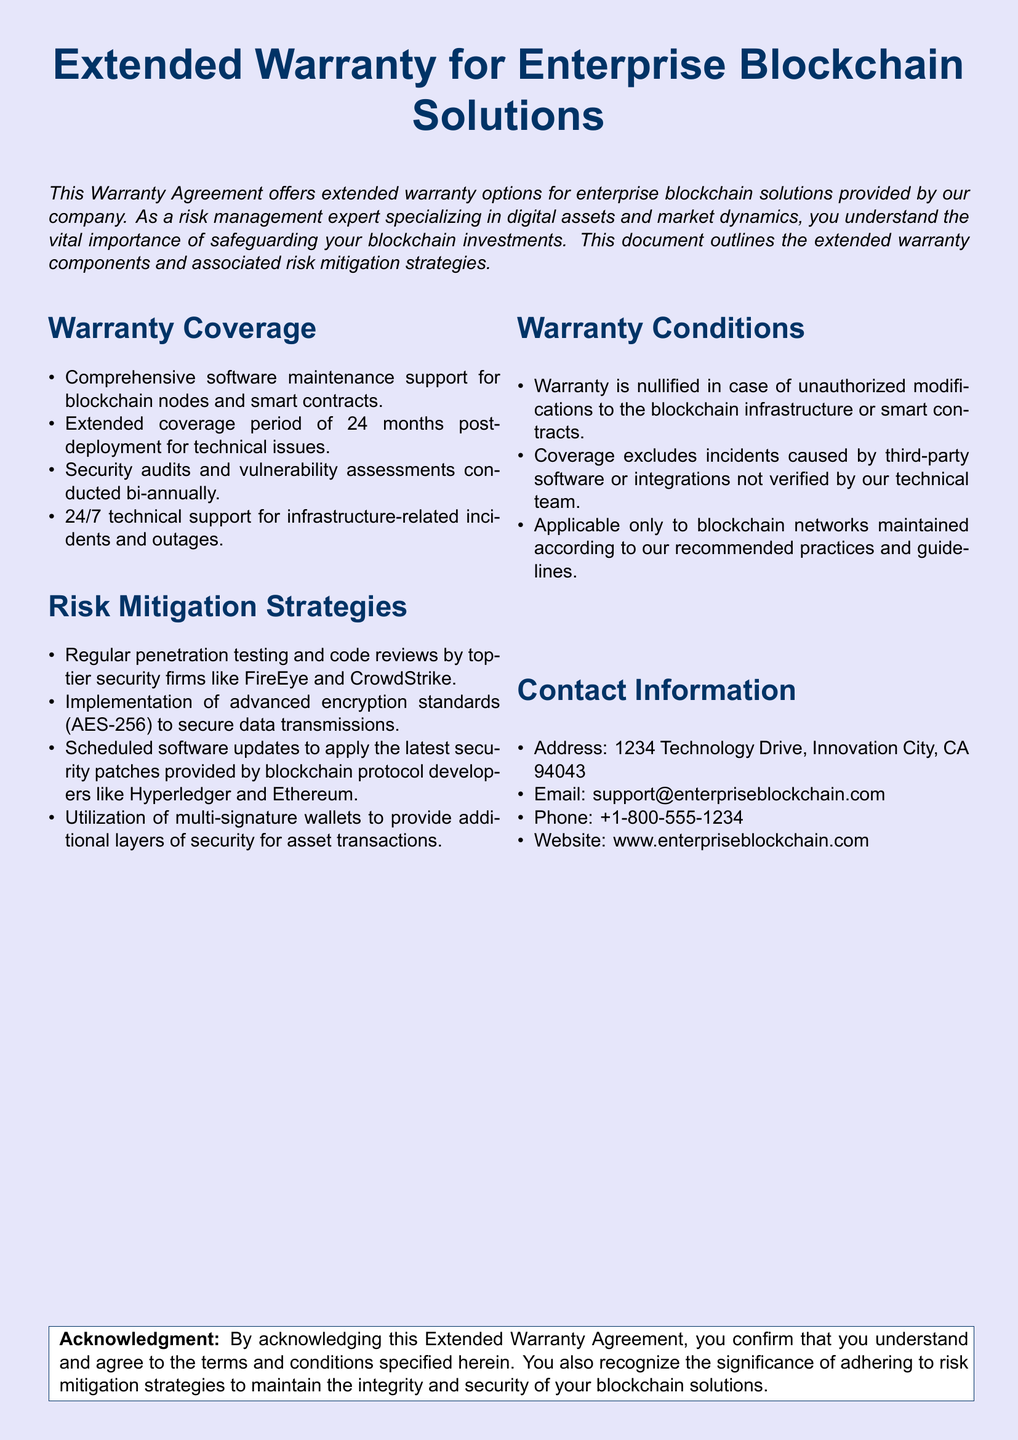What is the extended coverage period for technical issues? The extended coverage period for technical issues is clearly stated in the document.
Answer: 24 months What type of technical support is provided? The document specifies the kind of technical support included in the warranty agreement.
Answer: 24/7 technical support Which companies conduct the penetration testing? The document names the security firms responsible for conducting penetration testing and code reviews.
Answer: FireEye and CrowdStrike What encryption standard is implemented for data transmissions? The document mentions the encryption standard used to secure data transfers.
Answer: AES-256 What happens if there are unauthorized modifications made? The document outlines a specific condition under which the warranty becomes nullified.
Answer: Warranty is nullified What type of infrastructure incidents does the warranty cover? The document details the kinds of incidents related to infrastructure that are covered by the warranty.
Answer: Infrastructure-related incidents What is the contact email provided in the document? The document includes contact information including email for support queries.
Answer: support@enterpriseblockchain.com How often are security audits conducted? The document specifies the frequency of security audits and assessments.
Answer: Bi-annually Which blockchain networks does the warranty apply to? The document includes conditions under which the warranty is applicable to blockchain networks.
Answer: Maintained according to our recommended practices 